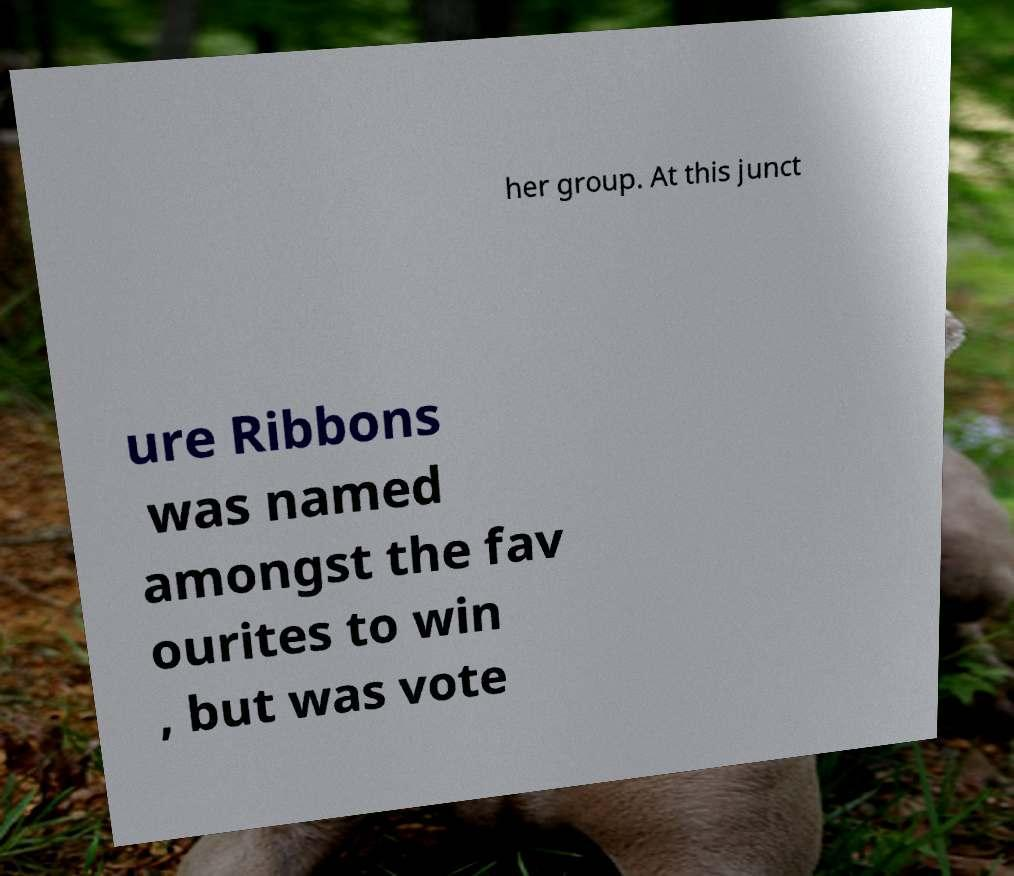Can you read and provide the text displayed in the image?This photo seems to have some interesting text. Can you extract and type it out for me? her group. At this junct ure Ribbons was named amongst the fav ourites to win , but was vote 